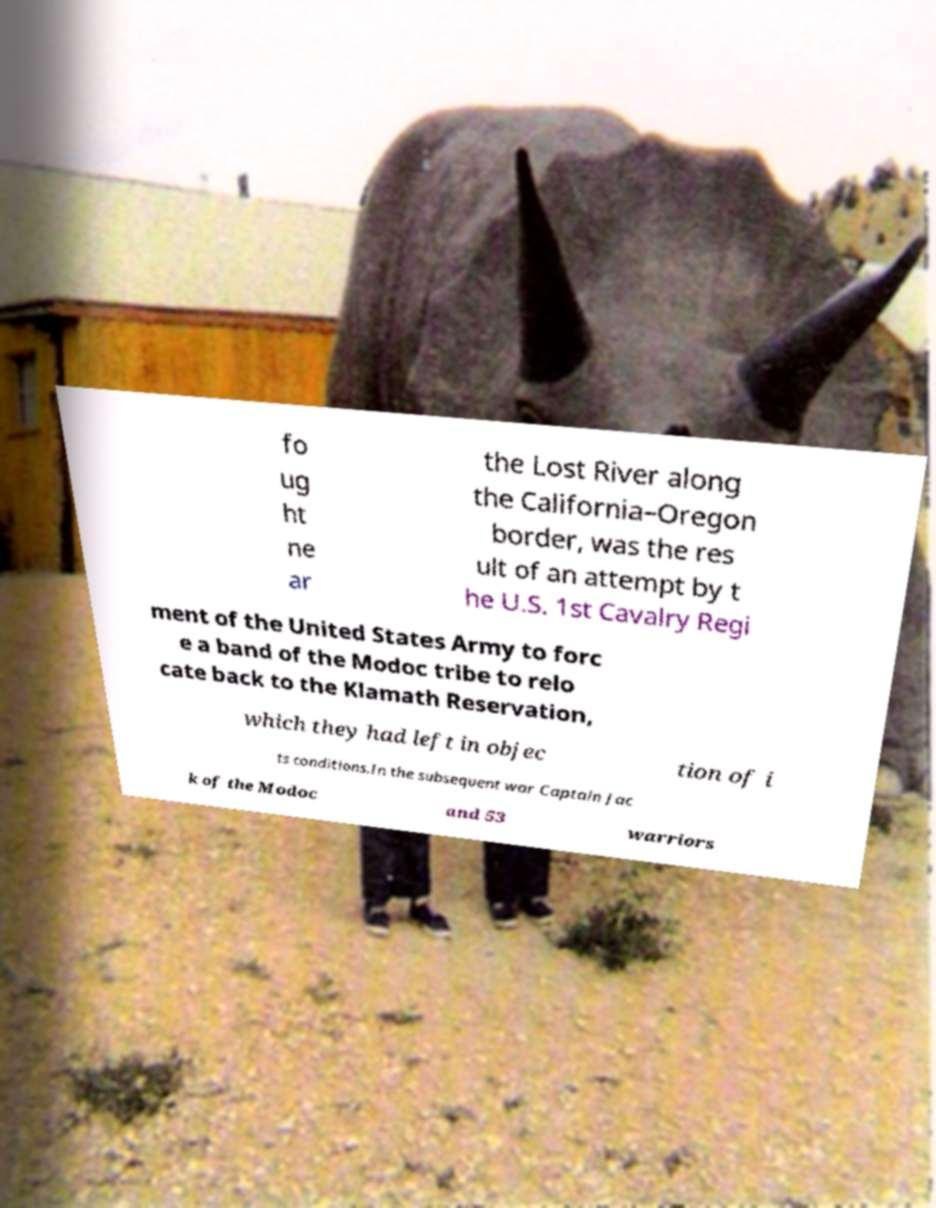For documentation purposes, I need the text within this image transcribed. Could you provide that? fo ug ht ne ar the Lost River along the California–Oregon border, was the res ult of an attempt by t he U.S. 1st Cavalry Regi ment of the United States Army to forc e a band of the Modoc tribe to relo cate back to the Klamath Reservation, which they had left in objec tion of i ts conditions.In the subsequent war Captain Jac k of the Modoc and 53 warriors 